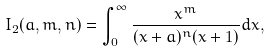<formula> <loc_0><loc_0><loc_500><loc_500>I _ { 2 } ( a , m , n ) = \int _ { 0 } ^ { \infty } \frac { x ^ { m } } { ( x + a ) ^ { n } ( x + 1 ) } d x ,</formula> 